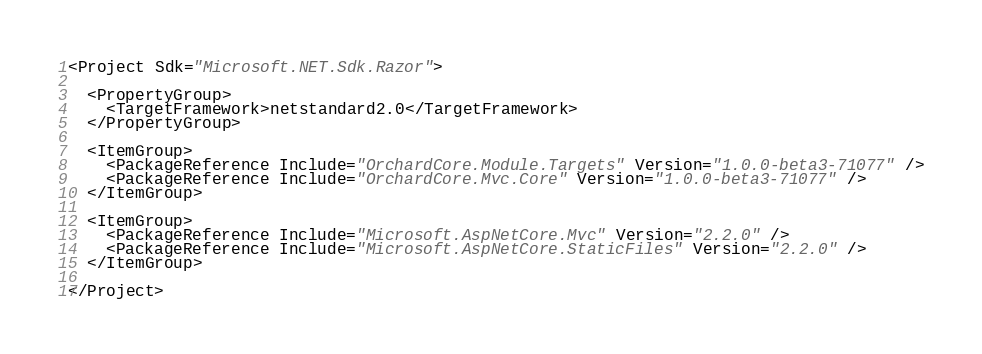<code> <loc_0><loc_0><loc_500><loc_500><_XML_><Project Sdk="Microsoft.NET.Sdk.Razor">

  <PropertyGroup>
    <TargetFramework>netstandard2.0</TargetFramework>
  </PropertyGroup>

  <ItemGroup>
    <PackageReference Include="OrchardCore.Module.Targets" Version="1.0.0-beta3-71077" />
    <PackageReference Include="OrchardCore.Mvc.Core" Version="1.0.0-beta3-71077" />
  </ItemGroup>

  <ItemGroup>
    <PackageReference Include="Microsoft.AspNetCore.Mvc" Version="2.2.0" />
    <PackageReference Include="Microsoft.AspNetCore.StaticFiles" Version="2.2.0" />
  </ItemGroup>

</Project>
</code> 